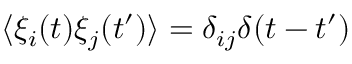<formula> <loc_0><loc_0><loc_500><loc_500>\langle \xi _ { i } ( t ) \xi _ { j } ( t ^ { \prime } ) \rangle = \delta _ { i j } \delta ( t - t ^ { \prime } )</formula> 